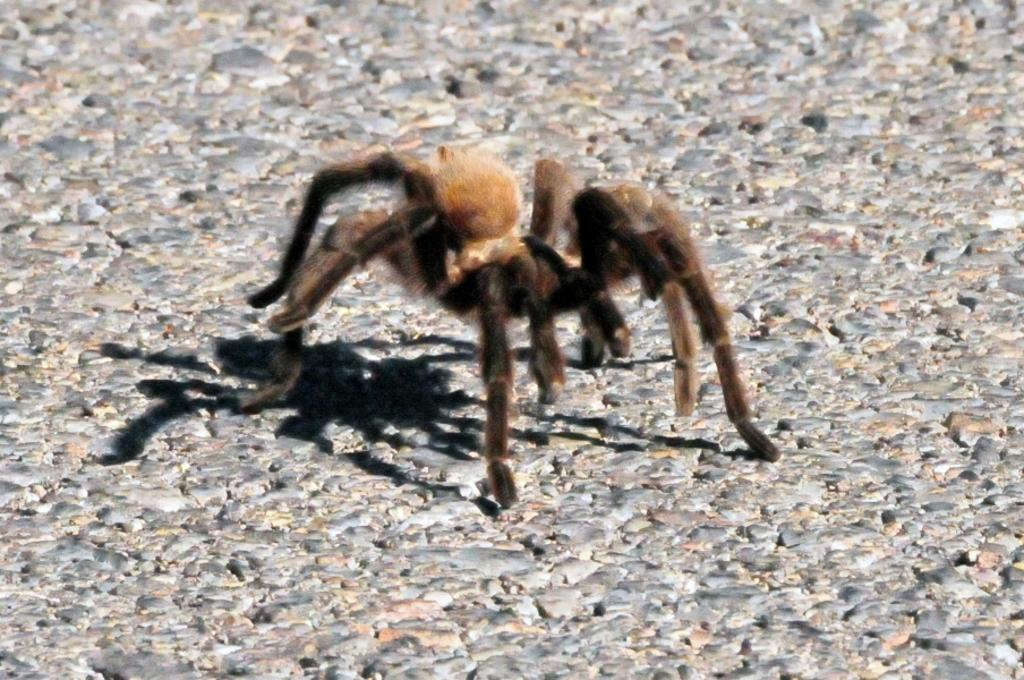What is present in the image? There is a spider in the image. Where is the spider's shadow located? The spider's shadow is on a rock surface. What type of cherry is the spider holding in its mouth in the image? There is no cherry present in the image, and the spider is not holding anything in its mouth. 